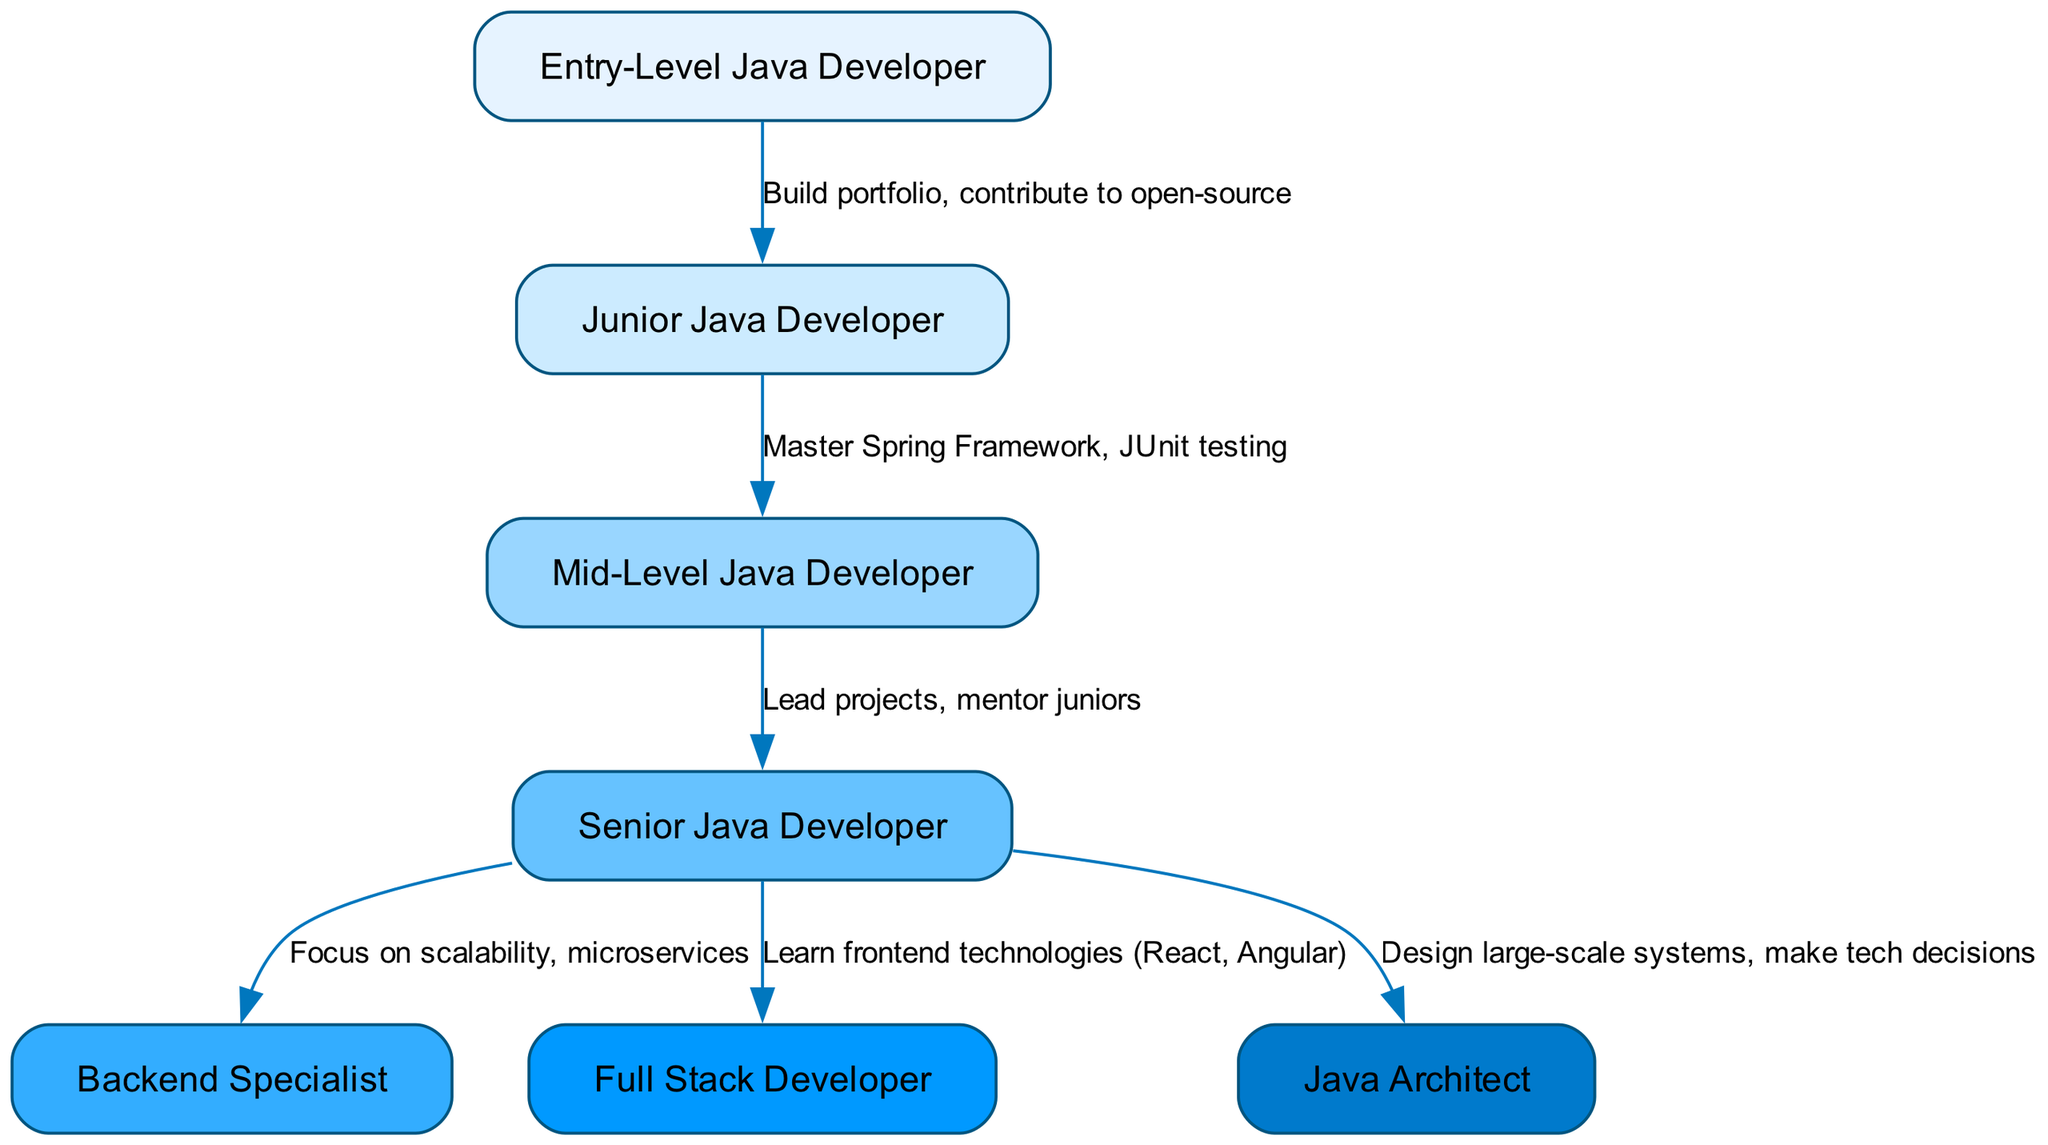What is the starting position in the career progression? The diagram shows that the entry point is labeled "Entry-Level Java Developer," indicating this is where one begins in their career path.
Answer: Entry-Level Java Developer How many nodes are present in the diagram? By counting each distinct job title in the diagram, we find there are a total of seven nodes representing different levels and specializations within the career pathway.
Answer: 7 What is the next position after Mid-Level Java Developer? The diagram indicates a direct transition from "Mid-Level Java Developer" to "Senior Java Developer" as the next step, showing a clear progression in career advancement.
Answer: Senior Java Developer What specialization can a Senior Java Developer choose related to back-end technologies? According to the diagram, a Senior Java Developer can specialize as a "Backend Specialist," focusing on specific skills applicable to backend development.
Answer: Backend Specialist Which position involves designing large-scale systems? The diagram clearly states that the role of "Java Architect" is responsible for designing large-scale systems, indicating a high level of expertise and responsibility.
Answer: Java Architect From which position do you transition to become a Full Stack Developer? The pathway shows that one can move to "Full Stack Developer" from "Senior Java Developer," demonstrating a shift towards full-stack competencies.
Answer: Senior Java Developer What is a requirement to progress from Junior to Mid-Level Java Developer? The pathway specifies "Master Spring Framework, JUnit testing" as the primary requirement to advance from the Junior level to Mid-Level status, emphasizing the need for specific technical skills.
Answer: Master Spring Framework, JUnit testing How many different specialization paths can a Senior Java Developer take? The diagram illustrates that a Senior Java Developer has three specialization paths including Backend Specialist, Full Stack Developer, and Java Architect, leading to diverse career options.
Answer: 3 What competences are necessary to advance to Senior Java Developer? The transition from "Mid-Level Java Developer" to "Senior Java Developer" requires leading projects and mentoring juniors, which reflects both leadership and technical skills acquired.
Answer: Lead projects, mentor juniors 